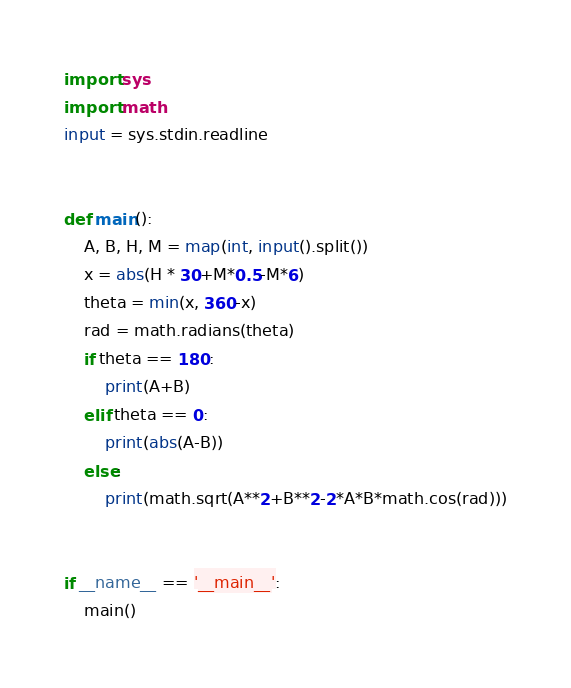<code> <loc_0><loc_0><loc_500><loc_500><_Python_>import sys
import math
input = sys.stdin.readline


def main():
    A, B, H, M = map(int, input().split())
    x = abs(H * 30+M*0.5-M*6)
    theta = min(x, 360-x)
    rad = math.radians(theta)
    if theta == 180:
        print(A+B)
    elif theta == 0:
        print(abs(A-B))
    else:
        print(math.sqrt(A**2+B**2-2*A*B*math.cos(rad)))


if __name__ == '__main__':
    main()
</code> 